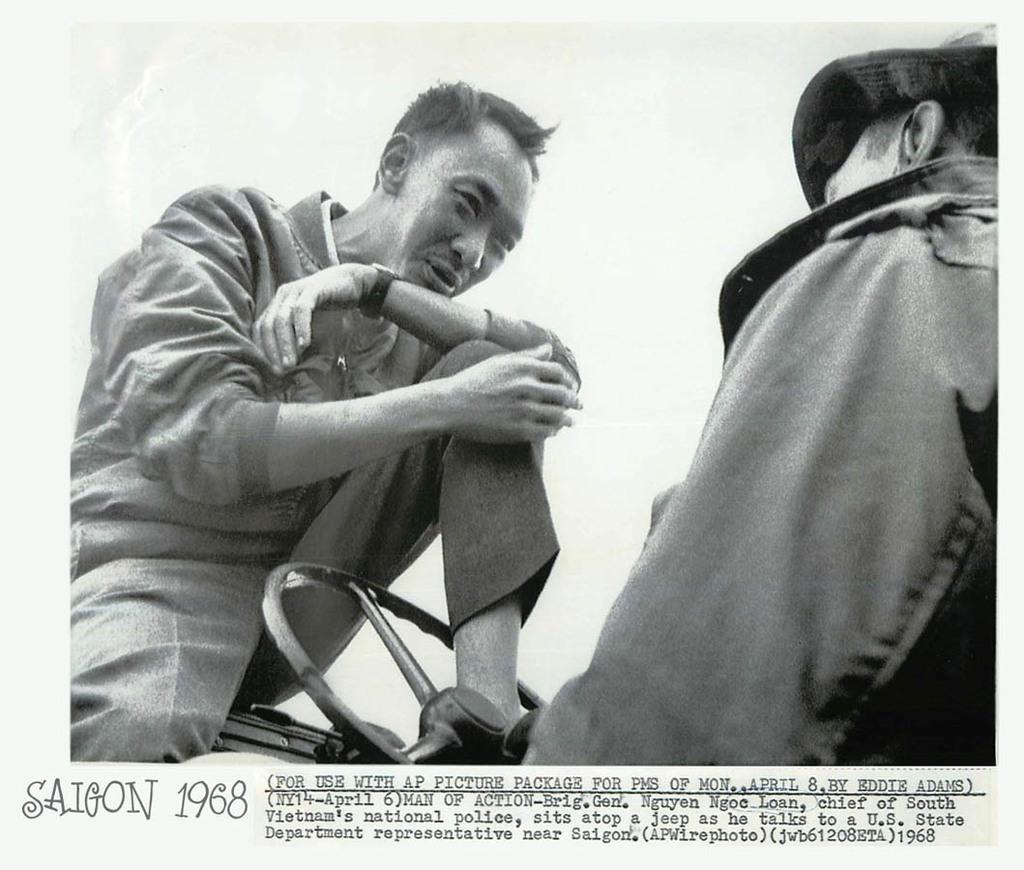How many men are visible in the image? There are two men in the image, one on the right side and another on the left side. What object can be seen between the two men? There is a steering wheel in the image. What is located at the bottom of the image? There is text at the bottom of the image. What color is the man's toe on the right side of the image? There is no man's toe visible in the image, as the focus is on the two men and the steering wheel. 